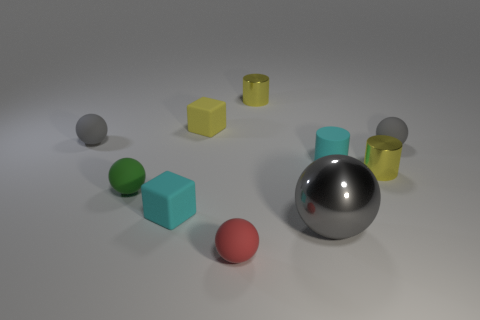Subtract all tiny red matte spheres. How many spheres are left? 4 Subtract all purple cubes. How many gray spheres are left? 3 Subtract 3 spheres. How many spheres are left? 2 Subtract all green balls. How many balls are left? 4 Subtract all red cylinders. Subtract all green spheres. How many cylinders are left? 3 Subtract all cylinders. How many objects are left? 7 Subtract all cyan balls. Subtract all large spheres. How many objects are left? 9 Add 8 tiny yellow metallic cylinders. How many tiny yellow metallic cylinders are left? 10 Add 4 large rubber balls. How many large rubber balls exist? 4 Subtract 0 green cylinders. How many objects are left? 10 